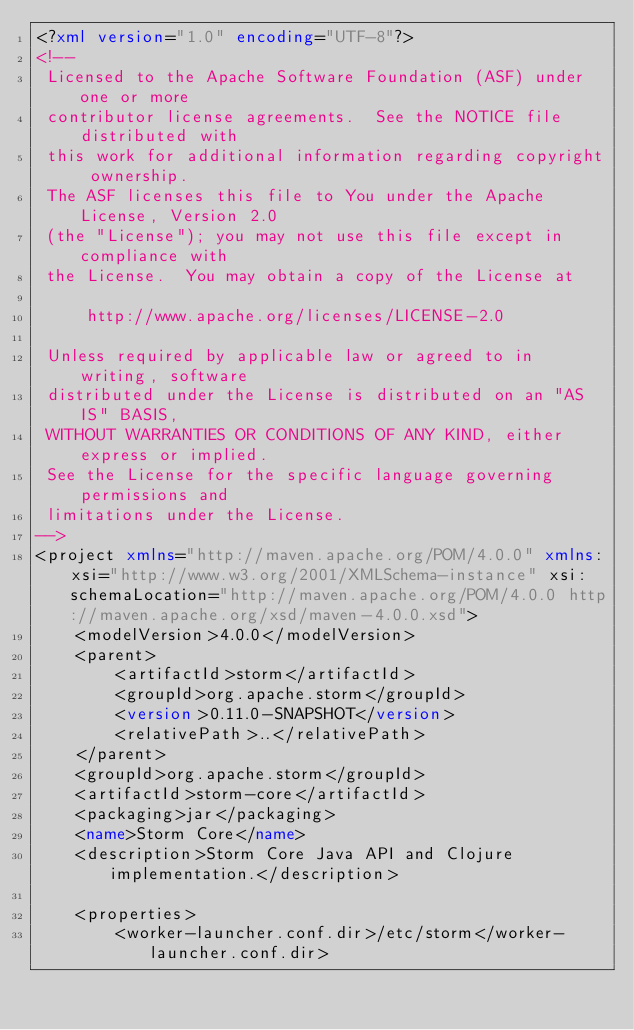<code> <loc_0><loc_0><loc_500><loc_500><_XML_><?xml version="1.0" encoding="UTF-8"?>
<!--
 Licensed to the Apache Software Foundation (ASF) under one or more
 contributor license agreements.  See the NOTICE file distributed with
 this work for additional information regarding copyright ownership.
 The ASF licenses this file to You under the Apache License, Version 2.0
 (the "License"); you may not use this file except in compliance with
 the License.  You may obtain a copy of the License at

     http://www.apache.org/licenses/LICENSE-2.0

 Unless required by applicable law or agreed to in writing, software
 distributed under the License is distributed on an "AS IS" BASIS,
 WITHOUT WARRANTIES OR CONDITIONS OF ANY KIND, either express or implied.
 See the License for the specific language governing permissions and
 limitations under the License.
-->
<project xmlns="http://maven.apache.org/POM/4.0.0" xmlns:xsi="http://www.w3.org/2001/XMLSchema-instance" xsi:schemaLocation="http://maven.apache.org/POM/4.0.0 http://maven.apache.org/xsd/maven-4.0.0.xsd">
    <modelVersion>4.0.0</modelVersion>
    <parent>
        <artifactId>storm</artifactId>
        <groupId>org.apache.storm</groupId>
        <version>0.11.0-SNAPSHOT</version>
        <relativePath>..</relativePath>
    </parent>
    <groupId>org.apache.storm</groupId>
    <artifactId>storm-core</artifactId>
    <packaging>jar</packaging>
    <name>Storm Core</name>
    <description>Storm Core Java API and Clojure implementation.</description>

    <properties>
        <worker-launcher.conf.dir>/etc/storm</worker-launcher.conf.dir></code> 